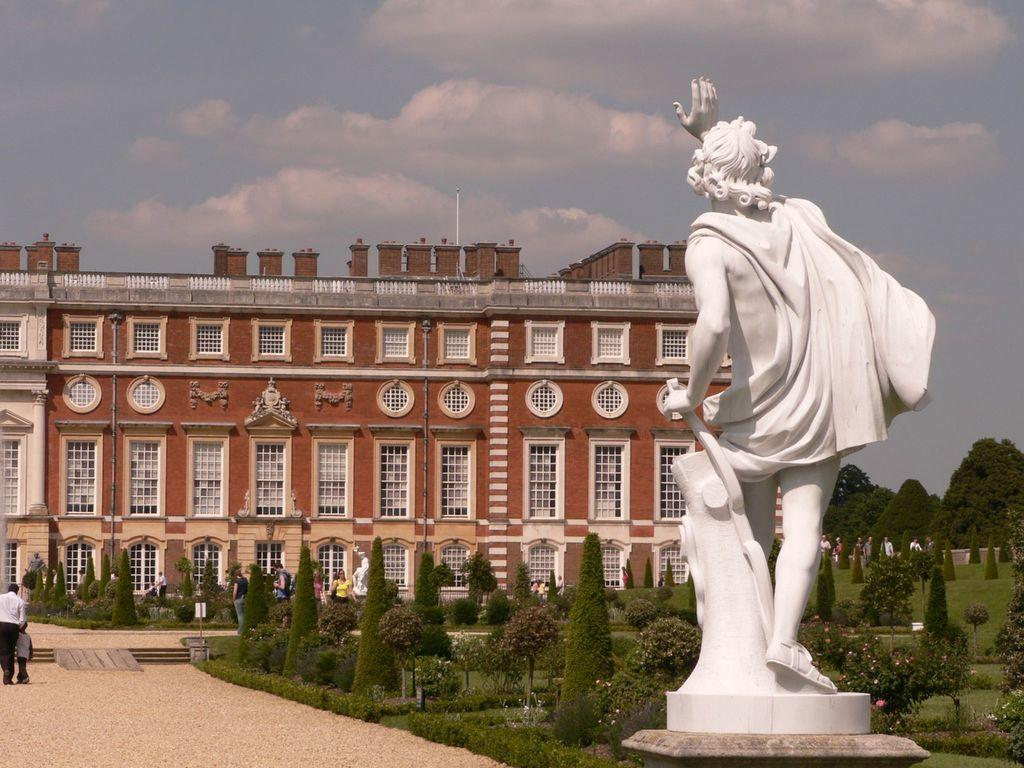What is the main subject in the image? There is a white color statue in the image. What type of vegetation can be seen in the image? There are plants and trees in the image. What is present on the ground in the right corner of the image? There is greenery on the ground in the right corner of the image. What can be seen in the background of the image? There are people and a building in the background of the image. What type of paint is being used by the monkey on the stage in the image? There is no monkey or stage present in the image. 